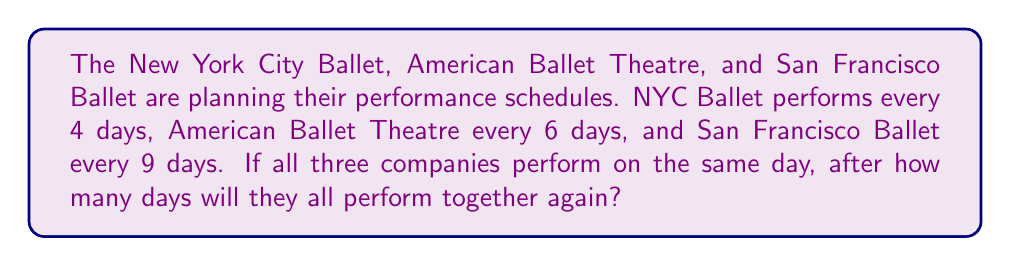Solve this math problem. To solve this problem, we need to find the least common multiple (LCM) of the performance intervals for the three ballet companies.

Step 1: Identify the intervals
- NYC Ballet: 4 days
- American Ballet Theatre: 6 days
- San Francisco Ballet: 9 days

Step 2: Find the prime factorization of each number
- 4 = $2^2$
- 6 = $2 \times 3$
- 9 = $3^2$

Step 3: To find the LCM, we take each prime factor to the highest power in which it occurs in any of the numbers:
- 2 appears with a maximum power of 2 (in 4)
- 3 appears with a maximum power of 2 (in 9)

Step 4: Multiply these factors together
$LCM = 2^2 \times 3^2 = 4 \times 9 = 36$

Therefore, the three ballet companies will all perform together again after 36 days.
Answer: 36 days 